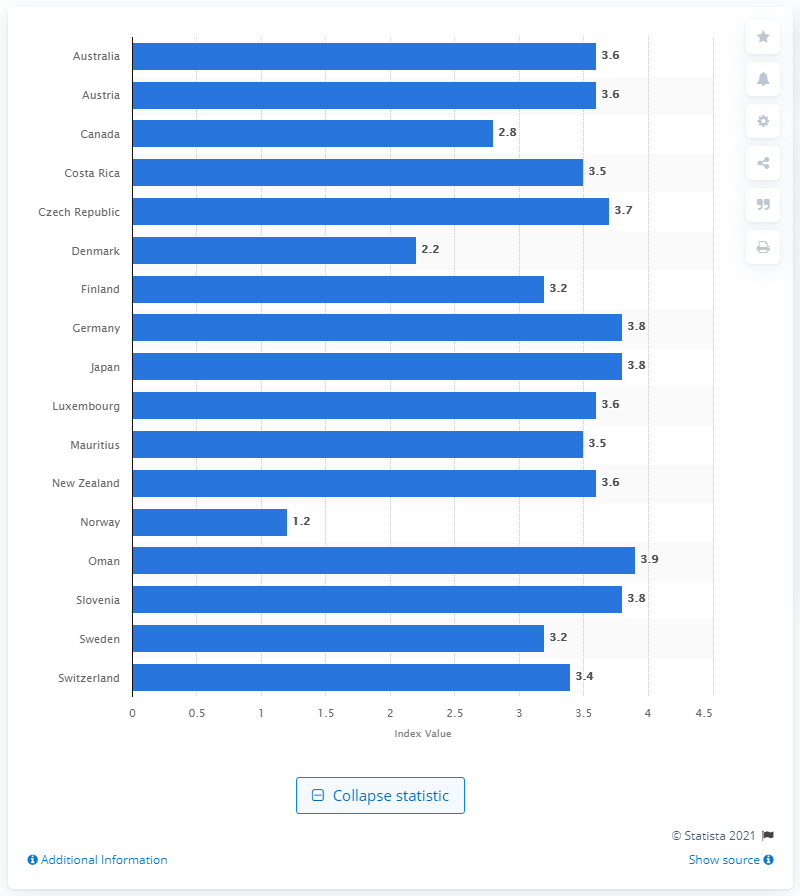List a handful of essential elements in this visual. In 2009 and 2010, Norway was the country with the highest level of political stability. 